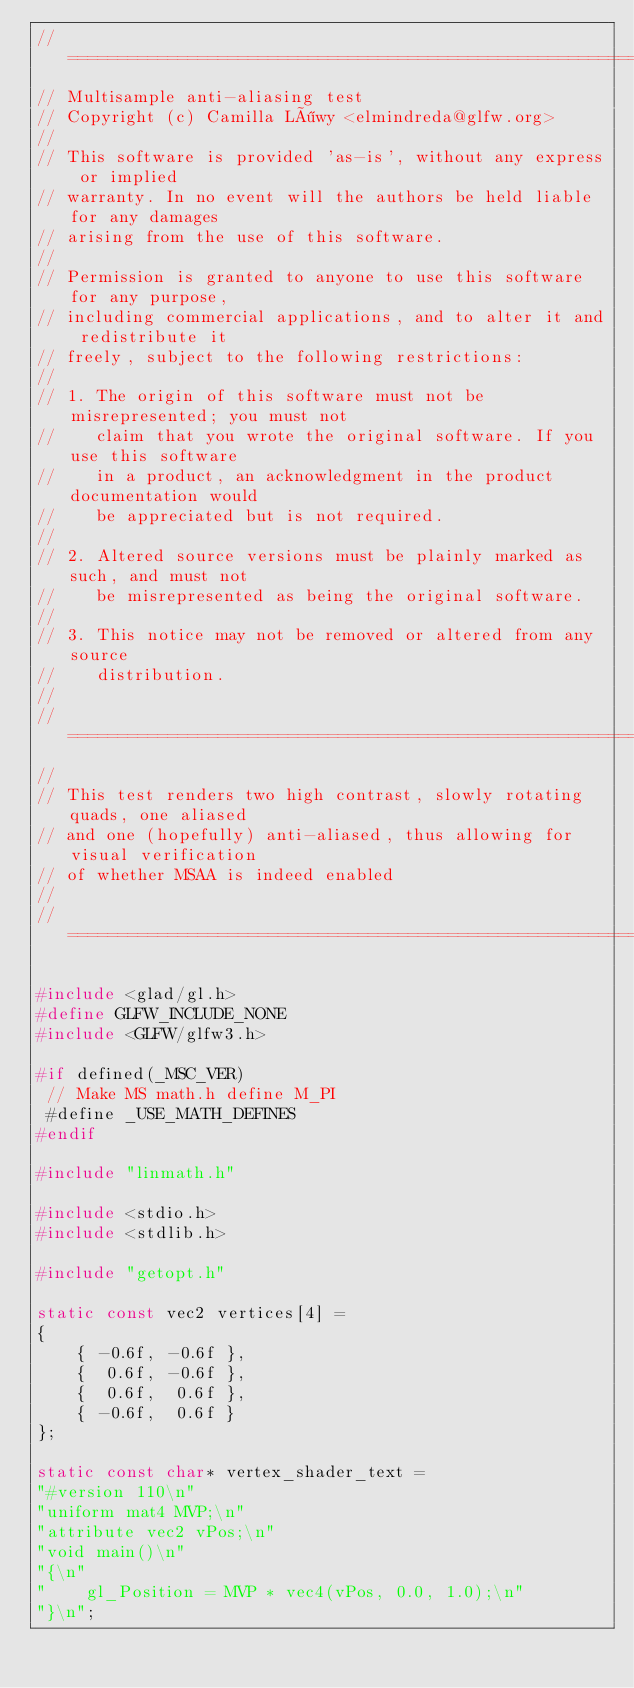Convert code to text. <code><loc_0><loc_0><loc_500><loc_500><_C_>//========================================================================
// Multisample anti-aliasing test
// Copyright (c) Camilla Löwy <elmindreda@glfw.org>
//
// This software is provided 'as-is', without any express or implied
// warranty. In no event will the authors be held liable for any damages
// arising from the use of this software.
//
// Permission is granted to anyone to use this software for any purpose,
// including commercial applications, and to alter it and redistribute it
// freely, subject to the following restrictions:
//
// 1. The origin of this software must not be misrepresented; you must not
//    claim that you wrote the original software. If you use this software
//    in a product, an acknowledgment in the product documentation would
//    be appreciated but is not required.
//
// 2. Altered source versions must be plainly marked as such, and must not
//    be misrepresented as being the original software.
//
// 3. This notice may not be removed or altered from any source
//    distribution.
//
//========================================================================
//
// This test renders two high contrast, slowly rotating quads, one aliased
// and one (hopefully) anti-aliased, thus allowing for visual verification
// of whether MSAA is indeed enabled
//
//========================================================================

#include <glad/gl.h>
#define GLFW_INCLUDE_NONE
#include <GLFW/glfw3.h>

#if defined(_MSC_VER)
 // Make MS math.h define M_PI
 #define _USE_MATH_DEFINES
#endif

#include "linmath.h"

#include <stdio.h>
#include <stdlib.h>

#include "getopt.h"

static const vec2 vertices[4] =
{
    { -0.6f, -0.6f },
    {  0.6f, -0.6f },
    {  0.6f,  0.6f },
    { -0.6f,  0.6f }
};

static const char* vertex_shader_text =
"#version 110\n"
"uniform mat4 MVP;\n"
"attribute vec2 vPos;\n"
"void main()\n"
"{\n"
"    gl_Position = MVP * vec4(vPos, 0.0, 1.0);\n"
"}\n";
</code> 